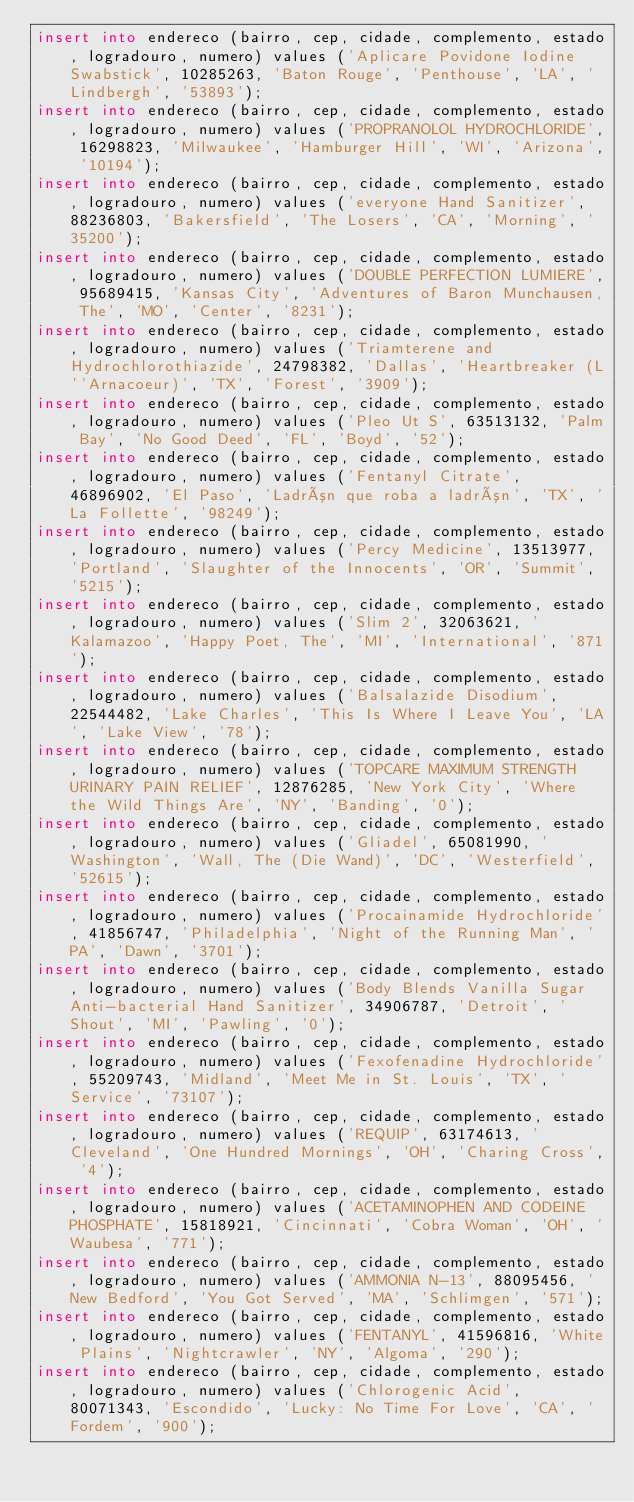Convert code to text. <code><loc_0><loc_0><loc_500><loc_500><_SQL_>insert into endereco (bairro, cep, cidade, complemento, estado, logradouro, numero) values ('Aplicare Povidone Iodine Swabstick', 10285263, 'Baton Rouge', 'Penthouse', 'LA', 'Lindbergh', '53893');
insert into endereco (bairro, cep, cidade, complemento, estado, logradouro, numero) values ('PROPRANOLOL HYDROCHLORIDE', 16298823, 'Milwaukee', 'Hamburger Hill', 'WI', 'Arizona', '10194');
insert into endereco (bairro, cep, cidade, complemento, estado, logradouro, numero) values ('everyone Hand Sanitizer', 88236803, 'Bakersfield', 'The Losers', 'CA', 'Morning', '35200');
insert into endereco (bairro, cep, cidade, complemento, estado, logradouro, numero) values ('DOUBLE PERFECTION LUMIERE', 95689415, 'Kansas City', 'Adventures of Baron Munchausen, The', 'MO', 'Center', '8231');
insert into endereco (bairro, cep, cidade, complemento, estado, logradouro, numero) values ('Triamterene and Hydrochlorothiazide', 24798382, 'Dallas', 'Heartbreaker (L''Arnacoeur)', 'TX', 'Forest', '3909');
insert into endereco (bairro, cep, cidade, complemento, estado, logradouro, numero) values ('Pleo Ut S', 63513132, 'Palm Bay', 'No Good Deed', 'FL', 'Boyd', '52');
insert into endereco (bairro, cep, cidade, complemento, estado, logradouro, numero) values ('Fentanyl Citrate', 46896902, 'El Paso', 'Ladrón que roba a ladrón', 'TX', 'La Follette', '98249');
insert into endereco (bairro, cep, cidade, complemento, estado, logradouro, numero) values ('Percy Medicine', 13513977, 'Portland', 'Slaughter of the Innocents', 'OR', 'Summit', '5215');
insert into endereco (bairro, cep, cidade, complemento, estado, logradouro, numero) values ('Slim 2', 32063621, 'Kalamazoo', 'Happy Poet, The', 'MI', 'International', '871');
insert into endereco (bairro, cep, cidade, complemento, estado, logradouro, numero) values ('Balsalazide Disodium', 22544482, 'Lake Charles', 'This Is Where I Leave You', 'LA', 'Lake View', '78');
insert into endereco (bairro, cep, cidade, complemento, estado, logradouro, numero) values ('TOPCARE MAXIMUM STRENGTH URINARY PAIN RELIEF', 12876285, 'New York City', 'Where the Wild Things Are', 'NY', 'Banding', '0');
insert into endereco (bairro, cep, cidade, complemento, estado, logradouro, numero) values ('Gliadel', 65081990, 'Washington', 'Wall, The (Die Wand)', 'DC', 'Westerfield', '52615');
insert into endereco (bairro, cep, cidade, complemento, estado, logradouro, numero) values ('Procainamide Hydrochloride', 41856747, 'Philadelphia', 'Night of the Running Man', 'PA', 'Dawn', '3701');
insert into endereco (bairro, cep, cidade, complemento, estado, logradouro, numero) values ('Body Blends Vanilla Sugar Anti-bacterial Hand Sanitizer', 34906787, 'Detroit', 'Shout', 'MI', 'Pawling', '0');
insert into endereco (bairro, cep, cidade, complemento, estado, logradouro, numero) values ('Fexofenadine Hydrochloride', 55209743, 'Midland', 'Meet Me in St. Louis', 'TX', 'Service', '73107');
insert into endereco (bairro, cep, cidade, complemento, estado, logradouro, numero) values ('REQUIP', 63174613, 'Cleveland', 'One Hundred Mornings', 'OH', 'Charing Cross', '4');
insert into endereco (bairro, cep, cidade, complemento, estado, logradouro, numero) values ('ACETAMINOPHEN AND CODEINE PHOSPHATE', 15818921, 'Cincinnati', 'Cobra Woman', 'OH', 'Waubesa', '771');
insert into endereco (bairro, cep, cidade, complemento, estado, logradouro, numero) values ('AMMONIA N-13', 88095456, 'New Bedford', 'You Got Served', 'MA', 'Schlimgen', '571');
insert into endereco (bairro, cep, cidade, complemento, estado, logradouro, numero) values ('FENTANYL', 41596816, 'White Plains', 'Nightcrawler', 'NY', 'Algoma', '290');
insert into endereco (bairro, cep, cidade, complemento, estado, logradouro, numero) values ('Chlorogenic Acid', 80071343, 'Escondido', 'Lucky: No Time For Love', 'CA', 'Fordem', '900');
</code> 